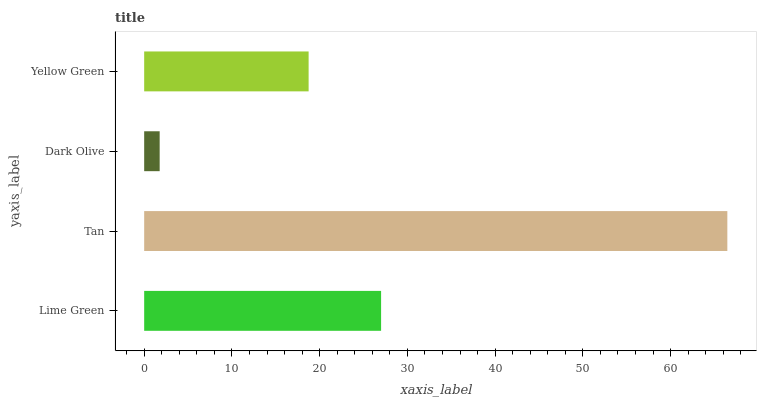Is Dark Olive the minimum?
Answer yes or no. Yes. Is Tan the maximum?
Answer yes or no. Yes. Is Tan the minimum?
Answer yes or no. No. Is Dark Olive the maximum?
Answer yes or no. No. Is Tan greater than Dark Olive?
Answer yes or no. Yes. Is Dark Olive less than Tan?
Answer yes or no. Yes. Is Dark Olive greater than Tan?
Answer yes or no. No. Is Tan less than Dark Olive?
Answer yes or no. No. Is Lime Green the high median?
Answer yes or no. Yes. Is Yellow Green the low median?
Answer yes or no. Yes. Is Dark Olive the high median?
Answer yes or no. No. Is Dark Olive the low median?
Answer yes or no. No. 